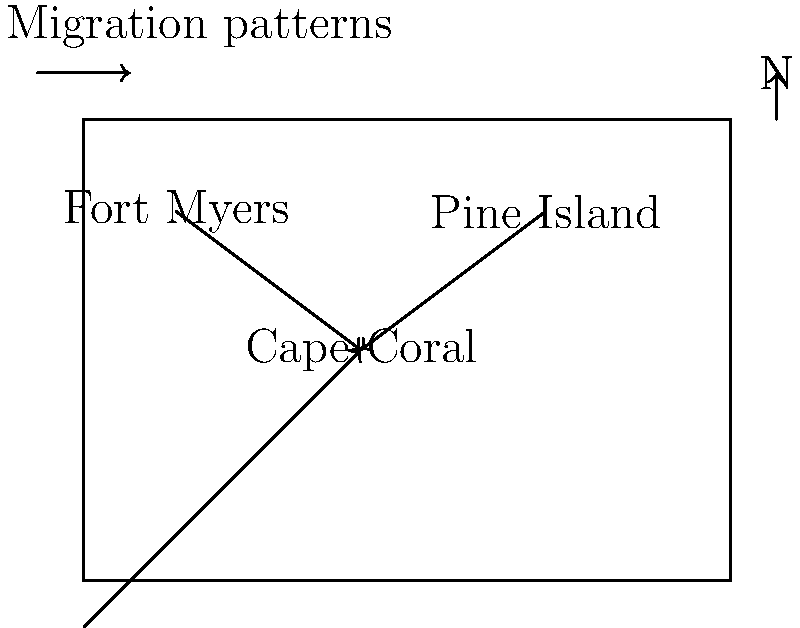Based on the migration patterns shown on the map, which of the following statements about early settlers in Cape Coral is most accurate? To answer this question, let's analyze the migration patterns shown on the map:

1. We can see three arrows pointing towards Cape Coral:
   a. One arrow coming from Fort Myers (to the northeast)
   b. One arrow coming from Pine Island (to the northwest)
   c. One arrow coming from the south (possibly representing overseas or out-of-state migration)

2. This pattern suggests that Cape Coral attracted settlers from multiple directions, including:
   - Nearby established communities (Fort Myers and Pine Island)
   - More distant locations (represented by the arrow from the south)

3. The convergence of these arrows on Cape Coral indicates that it was likely a new and growing settlement, attracting people from various surrounding areas.

4. The lack of arrows leading away from Cape Coral suggests that it was primarily a destination for settlers rather than a point of origin for further migration.

5. The presence of multiple arrows shows that Cape Coral's growth was not dependent on a single source of settlers but drew from diverse origins.

Given this analysis, the most accurate statement about early settlers in Cape Coral would be that they came from various surrounding areas and more distant locations, indicating that Cape Coral was a new and attractive settlement destination in the region.
Answer: Early settlers in Cape Coral came from diverse origins, including nearby communities and distant locations. 